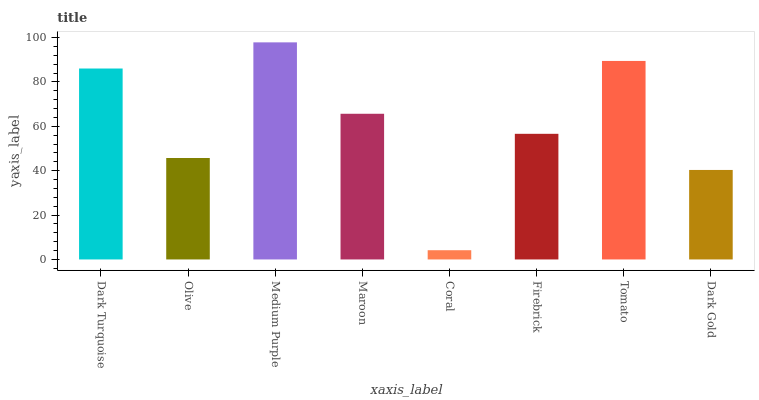Is Coral the minimum?
Answer yes or no. Yes. Is Medium Purple the maximum?
Answer yes or no. Yes. Is Olive the minimum?
Answer yes or no. No. Is Olive the maximum?
Answer yes or no. No. Is Dark Turquoise greater than Olive?
Answer yes or no. Yes. Is Olive less than Dark Turquoise?
Answer yes or no. Yes. Is Olive greater than Dark Turquoise?
Answer yes or no. No. Is Dark Turquoise less than Olive?
Answer yes or no. No. Is Maroon the high median?
Answer yes or no. Yes. Is Firebrick the low median?
Answer yes or no. Yes. Is Olive the high median?
Answer yes or no. No. Is Olive the low median?
Answer yes or no. No. 